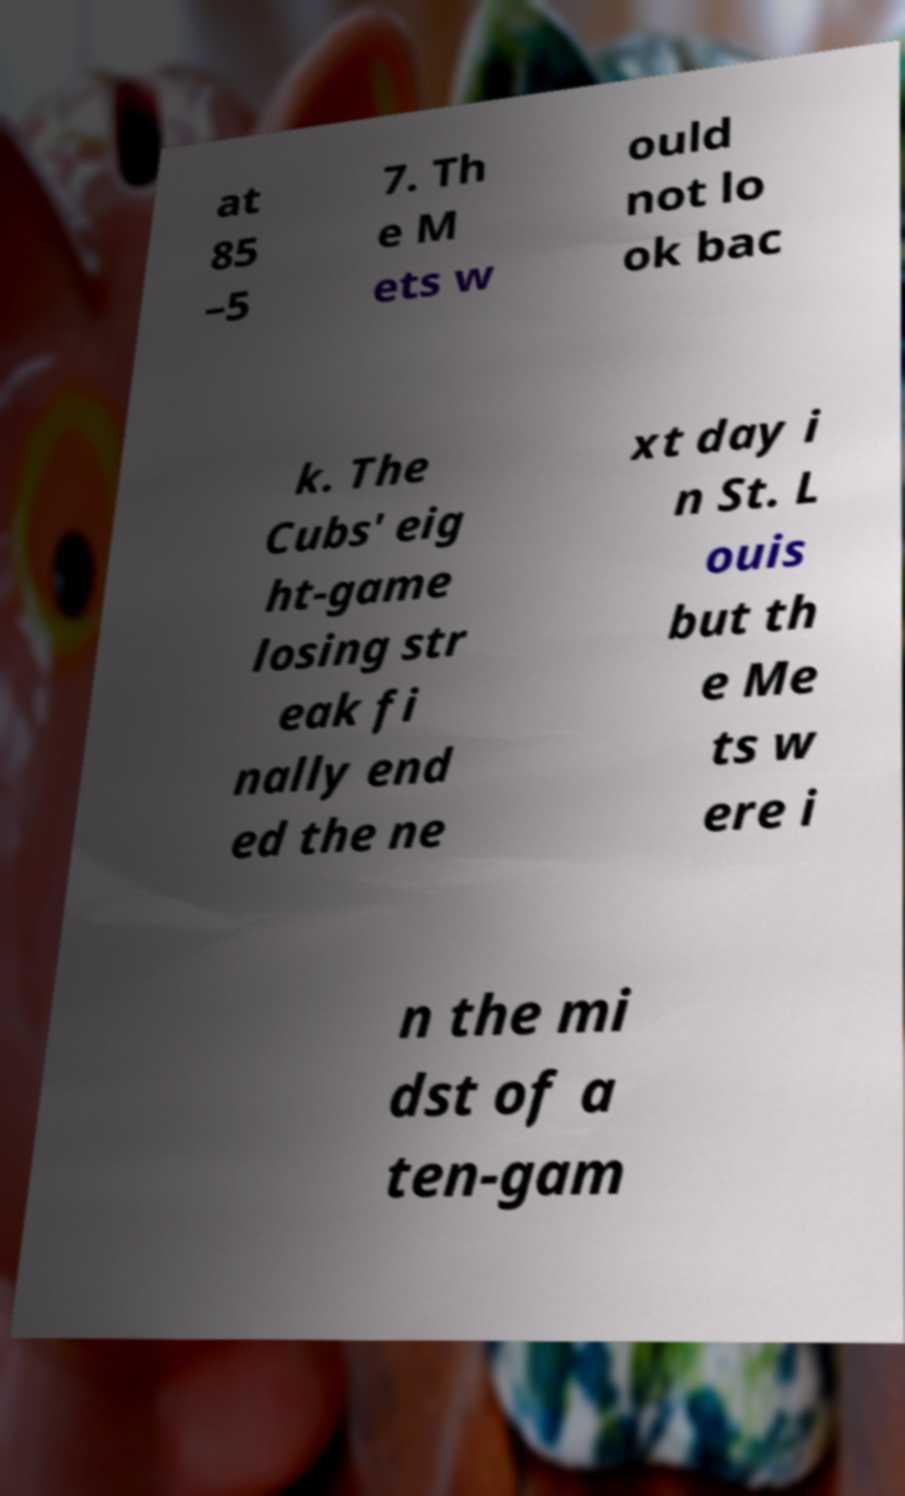Can you accurately transcribe the text from the provided image for me? at 85 –5 7. Th e M ets w ould not lo ok bac k. The Cubs' eig ht-game losing str eak fi nally end ed the ne xt day i n St. L ouis but th e Me ts w ere i n the mi dst of a ten-gam 